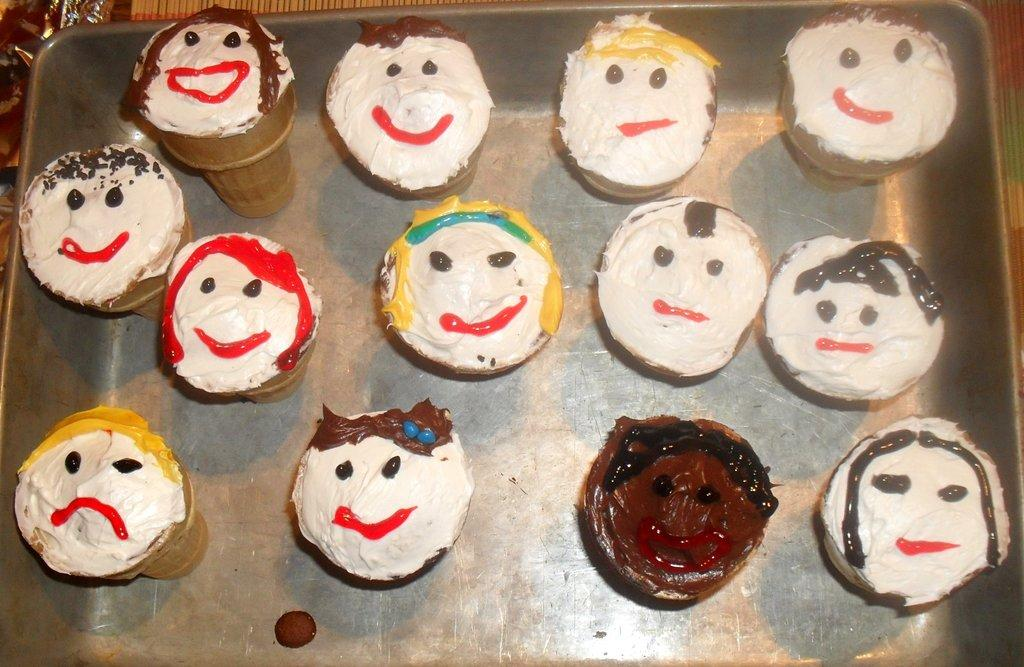What object is present in the image that can hold items? There is a tray in the image that can hold items. What is on the tray in the image? The tray contains ice creams. Can you describe the ice creams on the tray? The ice creams have designs on them. What type of food does the actor eat in the image? There is no actor or food present in the image; it only features a tray with ice creams. 